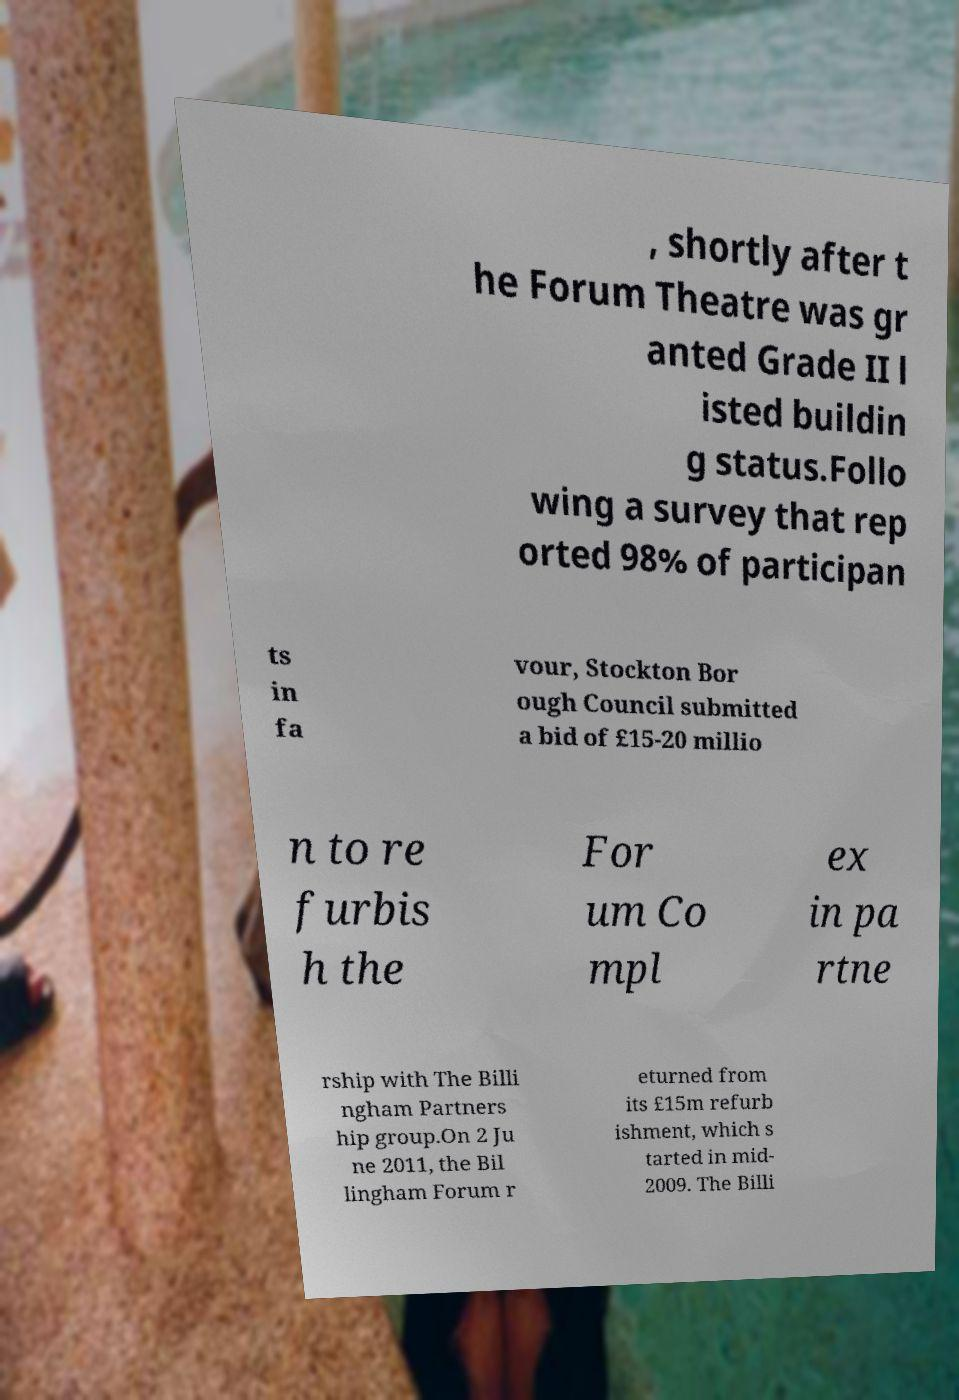Can you accurately transcribe the text from the provided image for me? , shortly after t he Forum Theatre was gr anted Grade II l isted buildin g status.Follo wing a survey that rep orted 98% of participan ts in fa vour, Stockton Bor ough Council submitted a bid of £15-20 millio n to re furbis h the For um Co mpl ex in pa rtne rship with The Billi ngham Partners hip group.On 2 Ju ne 2011, the Bil lingham Forum r eturned from its £15m refurb ishment, which s tarted in mid- 2009. The Billi 